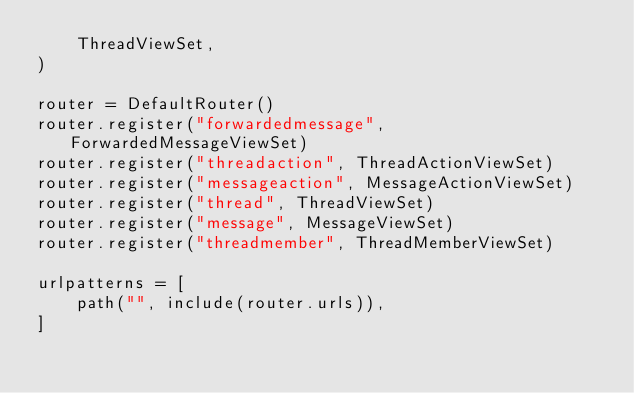<code> <loc_0><loc_0><loc_500><loc_500><_Python_>    ThreadViewSet,
)

router = DefaultRouter()
router.register("forwardedmessage", ForwardedMessageViewSet)
router.register("threadaction", ThreadActionViewSet)
router.register("messageaction", MessageActionViewSet)
router.register("thread", ThreadViewSet)
router.register("message", MessageViewSet)
router.register("threadmember", ThreadMemberViewSet)

urlpatterns = [
    path("", include(router.urls)),
]
</code> 